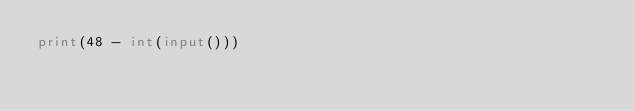Convert code to text. <code><loc_0><loc_0><loc_500><loc_500><_Python_>print(48 - int(input()))</code> 